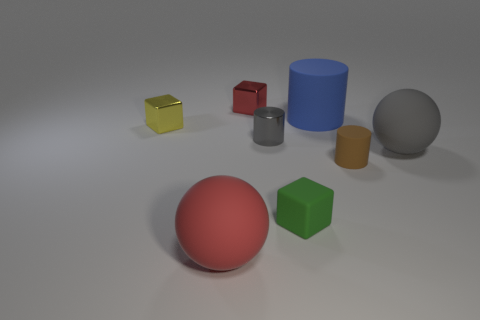Add 1 large rubber objects. How many objects exist? 9 Subtract all cubes. How many objects are left? 5 Add 1 brown cylinders. How many brown cylinders are left? 2 Add 4 small gray objects. How many small gray objects exist? 5 Subtract 0 yellow cylinders. How many objects are left? 8 Subtract all large matte cylinders. Subtract all tiny brown metallic cylinders. How many objects are left? 7 